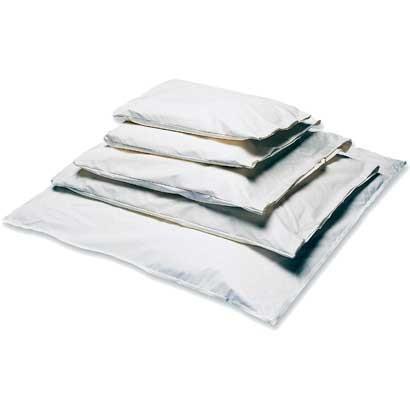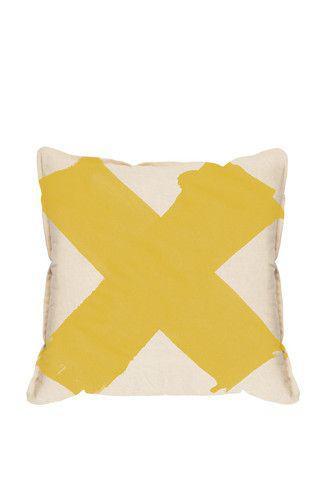The first image is the image on the left, the second image is the image on the right. Considering the images on both sides, is "The left image contains a single item." valid? Answer yes or no. No. 